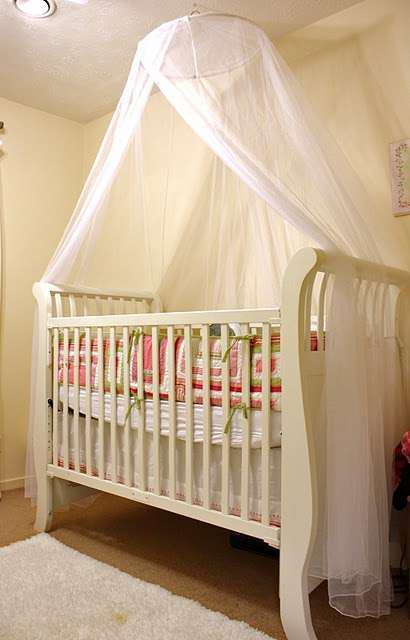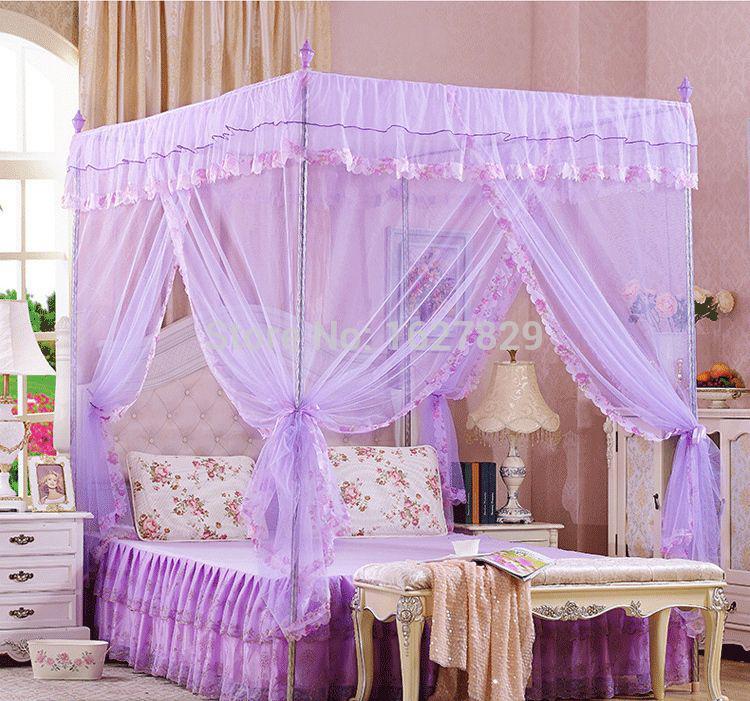The first image is the image on the left, the second image is the image on the right. Evaluate the accuracy of this statement regarding the images: "Exactly one bed has a round canopy.". Is it true? Answer yes or no. Yes. 